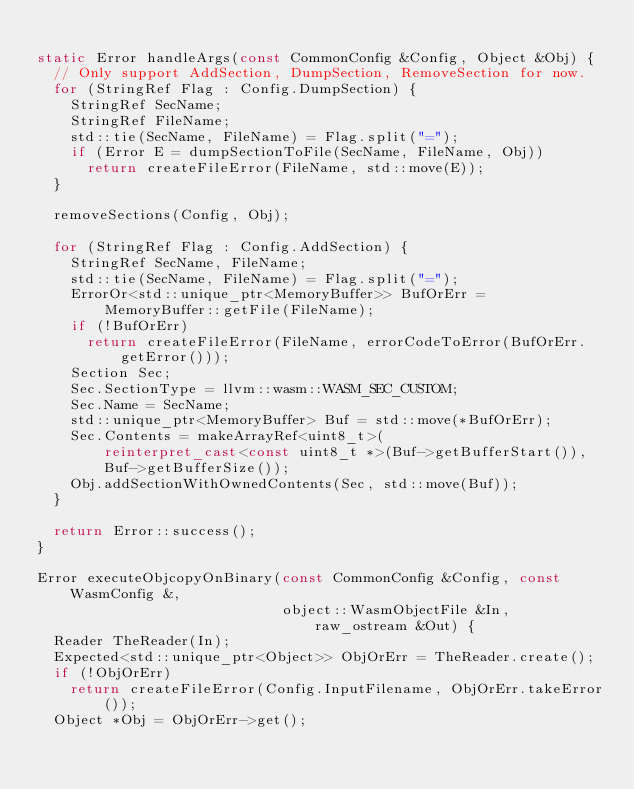<code> <loc_0><loc_0><loc_500><loc_500><_C++_>
static Error handleArgs(const CommonConfig &Config, Object &Obj) {
  // Only support AddSection, DumpSection, RemoveSection for now.
  for (StringRef Flag : Config.DumpSection) {
    StringRef SecName;
    StringRef FileName;
    std::tie(SecName, FileName) = Flag.split("=");
    if (Error E = dumpSectionToFile(SecName, FileName, Obj))
      return createFileError(FileName, std::move(E));
  }

  removeSections(Config, Obj);

  for (StringRef Flag : Config.AddSection) {
    StringRef SecName, FileName;
    std::tie(SecName, FileName) = Flag.split("=");
    ErrorOr<std::unique_ptr<MemoryBuffer>> BufOrErr =
        MemoryBuffer::getFile(FileName);
    if (!BufOrErr)
      return createFileError(FileName, errorCodeToError(BufOrErr.getError()));
    Section Sec;
    Sec.SectionType = llvm::wasm::WASM_SEC_CUSTOM;
    Sec.Name = SecName;
    std::unique_ptr<MemoryBuffer> Buf = std::move(*BufOrErr);
    Sec.Contents = makeArrayRef<uint8_t>(
        reinterpret_cast<const uint8_t *>(Buf->getBufferStart()),
        Buf->getBufferSize());
    Obj.addSectionWithOwnedContents(Sec, std::move(Buf));
  }

  return Error::success();
}

Error executeObjcopyOnBinary(const CommonConfig &Config, const WasmConfig &,
                             object::WasmObjectFile &In, raw_ostream &Out) {
  Reader TheReader(In);
  Expected<std::unique_ptr<Object>> ObjOrErr = TheReader.create();
  if (!ObjOrErr)
    return createFileError(Config.InputFilename, ObjOrErr.takeError());
  Object *Obj = ObjOrErr->get();</code> 